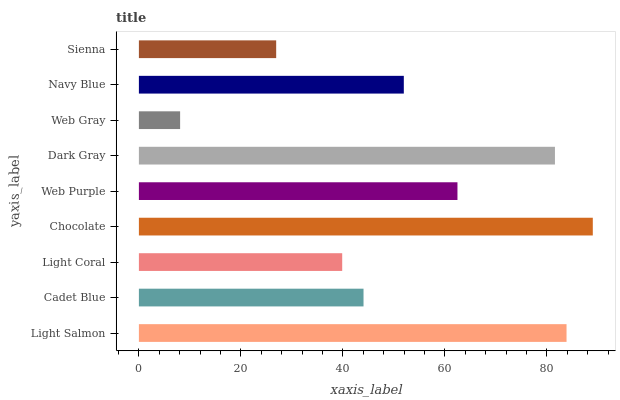Is Web Gray the minimum?
Answer yes or no. Yes. Is Chocolate the maximum?
Answer yes or no. Yes. Is Cadet Blue the minimum?
Answer yes or no. No. Is Cadet Blue the maximum?
Answer yes or no. No. Is Light Salmon greater than Cadet Blue?
Answer yes or no. Yes. Is Cadet Blue less than Light Salmon?
Answer yes or no. Yes. Is Cadet Blue greater than Light Salmon?
Answer yes or no. No. Is Light Salmon less than Cadet Blue?
Answer yes or no. No. Is Navy Blue the high median?
Answer yes or no. Yes. Is Navy Blue the low median?
Answer yes or no. Yes. Is Light Coral the high median?
Answer yes or no. No. Is Chocolate the low median?
Answer yes or no. No. 